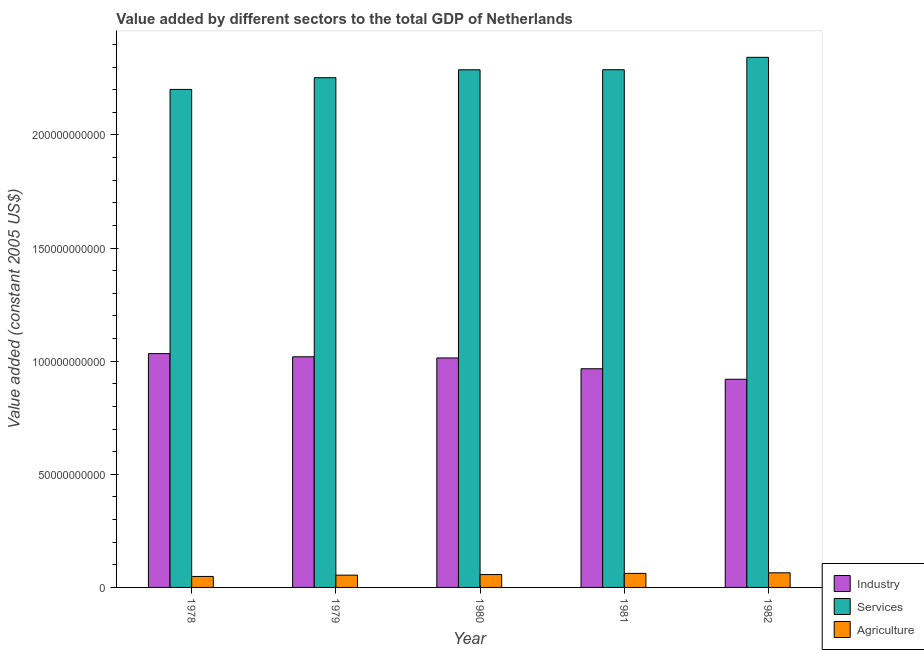How many different coloured bars are there?
Your response must be concise. 3. How many groups of bars are there?
Provide a succinct answer. 5. Are the number of bars on each tick of the X-axis equal?
Make the answer very short. Yes. How many bars are there on the 1st tick from the right?
Make the answer very short. 3. What is the label of the 4th group of bars from the left?
Provide a succinct answer. 1981. What is the value added by services in 1978?
Offer a very short reply. 2.20e+11. Across all years, what is the maximum value added by industrial sector?
Make the answer very short. 1.03e+11. Across all years, what is the minimum value added by agricultural sector?
Your answer should be compact. 4.85e+09. In which year was the value added by agricultural sector maximum?
Your answer should be compact. 1982. What is the total value added by industrial sector in the graph?
Your response must be concise. 4.95e+11. What is the difference between the value added by industrial sector in 1979 and that in 1981?
Provide a short and direct response. 5.29e+09. What is the difference between the value added by agricultural sector in 1982 and the value added by industrial sector in 1978?
Your response must be concise. 1.61e+09. What is the average value added by agricultural sector per year?
Make the answer very short. 5.73e+09. In how many years, is the value added by agricultural sector greater than 200000000000 US$?
Offer a very short reply. 0. What is the ratio of the value added by services in 1978 to that in 1982?
Offer a terse response. 0.94. What is the difference between the highest and the second highest value added by agricultural sector?
Offer a terse response. 2.62e+08. What is the difference between the highest and the lowest value added by industrial sector?
Provide a succinct answer. 1.13e+1. In how many years, is the value added by agricultural sector greater than the average value added by agricultural sector taken over all years?
Provide a short and direct response. 2. What does the 2nd bar from the left in 1981 represents?
Ensure brevity in your answer.  Services. What does the 3rd bar from the right in 1978 represents?
Provide a short and direct response. Industry. Is it the case that in every year, the sum of the value added by industrial sector and value added by services is greater than the value added by agricultural sector?
Offer a very short reply. Yes. Are all the bars in the graph horizontal?
Keep it short and to the point. No. How many years are there in the graph?
Ensure brevity in your answer.  5. Are the values on the major ticks of Y-axis written in scientific E-notation?
Your answer should be very brief. No. Does the graph contain any zero values?
Offer a terse response. No. Does the graph contain grids?
Offer a very short reply. No. Where does the legend appear in the graph?
Provide a short and direct response. Bottom right. How are the legend labels stacked?
Give a very brief answer. Vertical. What is the title of the graph?
Your answer should be compact. Value added by different sectors to the total GDP of Netherlands. Does "Communicable diseases" appear as one of the legend labels in the graph?
Provide a short and direct response. No. What is the label or title of the Y-axis?
Your answer should be very brief. Value added (constant 2005 US$). What is the Value added (constant 2005 US$) in Industry in 1978?
Offer a terse response. 1.03e+11. What is the Value added (constant 2005 US$) in Services in 1978?
Ensure brevity in your answer.  2.20e+11. What is the Value added (constant 2005 US$) of Agriculture in 1978?
Offer a very short reply. 4.85e+09. What is the Value added (constant 2005 US$) of Industry in 1979?
Your answer should be very brief. 1.02e+11. What is the Value added (constant 2005 US$) of Services in 1979?
Make the answer very short. 2.25e+11. What is the Value added (constant 2005 US$) of Agriculture in 1979?
Give a very brief answer. 5.43e+09. What is the Value added (constant 2005 US$) of Industry in 1980?
Offer a very short reply. 1.01e+11. What is the Value added (constant 2005 US$) of Services in 1980?
Make the answer very short. 2.29e+11. What is the Value added (constant 2005 US$) in Agriculture in 1980?
Your answer should be compact. 5.69e+09. What is the Value added (constant 2005 US$) in Industry in 1981?
Your answer should be very brief. 9.67e+1. What is the Value added (constant 2005 US$) of Services in 1981?
Provide a succinct answer. 2.29e+11. What is the Value added (constant 2005 US$) of Agriculture in 1981?
Your response must be concise. 6.20e+09. What is the Value added (constant 2005 US$) in Industry in 1982?
Offer a terse response. 9.20e+1. What is the Value added (constant 2005 US$) in Services in 1982?
Offer a terse response. 2.34e+11. What is the Value added (constant 2005 US$) in Agriculture in 1982?
Your answer should be very brief. 6.46e+09. Across all years, what is the maximum Value added (constant 2005 US$) of Industry?
Make the answer very short. 1.03e+11. Across all years, what is the maximum Value added (constant 2005 US$) in Services?
Make the answer very short. 2.34e+11. Across all years, what is the maximum Value added (constant 2005 US$) in Agriculture?
Make the answer very short. 6.46e+09. Across all years, what is the minimum Value added (constant 2005 US$) of Industry?
Keep it short and to the point. 9.20e+1. Across all years, what is the minimum Value added (constant 2005 US$) in Services?
Your answer should be very brief. 2.20e+11. Across all years, what is the minimum Value added (constant 2005 US$) in Agriculture?
Keep it short and to the point. 4.85e+09. What is the total Value added (constant 2005 US$) in Industry in the graph?
Ensure brevity in your answer.  4.95e+11. What is the total Value added (constant 2005 US$) of Services in the graph?
Make the answer very short. 1.14e+12. What is the total Value added (constant 2005 US$) in Agriculture in the graph?
Keep it short and to the point. 2.86e+1. What is the difference between the Value added (constant 2005 US$) of Industry in 1978 and that in 1979?
Offer a very short reply. 1.40e+09. What is the difference between the Value added (constant 2005 US$) in Services in 1978 and that in 1979?
Your answer should be compact. -5.17e+09. What is the difference between the Value added (constant 2005 US$) of Agriculture in 1978 and that in 1979?
Keep it short and to the point. -5.73e+08. What is the difference between the Value added (constant 2005 US$) of Industry in 1978 and that in 1980?
Make the answer very short. 1.91e+09. What is the difference between the Value added (constant 2005 US$) of Services in 1978 and that in 1980?
Offer a terse response. -8.68e+09. What is the difference between the Value added (constant 2005 US$) in Agriculture in 1978 and that in 1980?
Ensure brevity in your answer.  -8.32e+08. What is the difference between the Value added (constant 2005 US$) of Industry in 1978 and that in 1981?
Make the answer very short. 6.69e+09. What is the difference between the Value added (constant 2005 US$) in Services in 1978 and that in 1981?
Your answer should be very brief. -8.70e+09. What is the difference between the Value added (constant 2005 US$) of Agriculture in 1978 and that in 1981?
Offer a very short reply. -1.34e+09. What is the difference between the Value added (constant 2005 US$) of Industry in 1978 and that in 1982?
Provide a succinct answer. 1.13e+1. What is the difference between the Value added (constant 2005 US$) of Services in 1978 and that in 1982?
Keep it short and to the point. -1.42e+1. What is the difference between the Value added (constant 2005 US$) in Agriculture in 1978 and that in 1982?
Ensure brevity in your answer.  -1.61e+09. What is the difference between the Value added (constant 2005 US$) of Industry in 1979 and that in 1980?
Provide a short and direct response. 5.14e+08. What is the difference between the Value added (constant 2005 US$) of Services in 1979 and that in 1980?
Give a very brief answer. -3.51e+09. What is the difference between the Value added (constant 2005 US$) in Agriculture in 1979 and that in 1980?
Your answer should be compact. -2.59e+08. What is the difference between the Value added (constant 2005 US$) of Industry in 1979 and that in 1981?
Provide a succinct answer. 5.29e+09. What is the difference between the Value added (constant 2005 US$) of Services in 1979 and that in 1981?
Provide a short and direct response. -3.53e+09. What is the difference between the Value added (constant 2005 US$) in Agriculture in 1979 and that in 1981?
Keep it short and to the point. -7.72e+08. What is the difference between the Value added (constant 2005 US$) in Industry in 1979 and that in 1982?
Provide a short and direct response. 9.93e+09. What is the difference between the Value added (constant 2005 US$) in Services in 1979 and that in 1982?
Keep it short and to the point. -9.01e+09. What is the difference between the Value added (constant 2005 US$) in Agriculture in 1979 and that in 1982?
Your response must be concise. -1.03e+09. What is the difference between the Value added (constant 2005 US$) of Industry in 1980 and that in 1981?
Give a very brief answer. 4.78e+09. What is the difference between the Value added (constant 2005 US$) of Services in 1980 and that in 1981?
Provide a short and direct response. -2.19e+07. What is the difference between the Value added (constant 2005 US$) in Agriculture in 1980 and that in 1981?
Offer a very short reply. -5.13e+08. What is the difference between the Value added (constant 2005 US$) of Industry in 1980 and that in 1982?
Make the answer very short. 9.42e+09. What is the difference between the Value added (constant 2005 US$) of Services in 1980 and that in 1982?
Keep it short and to the point. -5.50e+09. What is the difference between the Value added (constant 2005 US$) of Agriculture in 1980 and that in 1982?
Provide a short and direct response. -7.75e+08. What is the difference between the Value added (constant 2005 US$) of Industry in 1981 and that in 1982?
Offer a terse response. 4.64e+09. What is the difference between the Value added (constant 2005 US$) in Services in 1981 and that in 1982?
Offer a very short reply. -5.48e+09. What is the difference between the Value added (constant 2005 US$) in Agriculture in 1981 and that in 1982?
Your response must be concise. -2.62e+08. What is the difference between the Value added (constant 2005 US$) of Industry in 1978 and the Value added (constant 2005 US$) of Services in 1979?
Your answer should be very brief. -1.22e+11. What is the difference between the Value added (constant 2005 US$) in Industry in 1978 and the Value added (constant 2005 US$) in Agriculture in 1979?
Give a very brief answer. 9.79e+1. What is the difference between the Value added (constant 2005 US$) of Services in 1978 and the Value added (constant 2005 US$) of Agriculture in 1979?
Ensure brevity in your answer.  2.15e+11. What is the difference between the Value added (constant 2005 US$) in Industry in 1978 and the Value added (constant 2005 US$) in Services in 1980?
Your response must be concise. -1.25e+11. What is the difference between the Value added (constant 2005 US$) of Industry in 1978 and the Value added (constant 2005 US$) of Agriculture in 1980?
Offer a very short reply. 9.77e+1. What is the difference between the Value added (constant 2005 US$) in Services in 1978 and the Value added (constant 2005 US$) in Agriculture in 1980?
Your answer should be very brief. 2.14e+11. What is the difference between the Value added (constant 2005 US$) in Industry in 1978 and the Value added (constant 2005 US$) in Services in 1981?
Provide a short and direct response. -1.25e+11. What is the difference between the Value added (constant 2005 US$) of Industry in 1978 and the Value added (constant 2005 US$) of Agriculture in 1981?
Make the answer very short. 9.71e+1. What is the difference between the Value added (constant 2005 US$) in Services in 1978 and the Value added (constant 2005 US$) in Agriculture in 1981?
Ensure brevity in your answer.  2.14e+11. What is the difference between the Value added (constant 2005 US$) of Industry in 1978 and the Value added (constant 2005 US$) of Services in 1982?
Offer a terse response. -1.31e+11. What is the difference between the Value added (constant 2005 US$) of Industry in 1978 and the Value added (constant 2005 US$) of Agriculture in 1982?
Offer a terse response. 9.69e+1. What is the difference between the Value added (constant 2005 US$) of Services in 1978 and the Value added (constant 2005 US$) of Agriculture in 1982?
Offer a terse response. 2.14e+11. What is the difference between the Value added (constant 2005 US$) of Industry in 1979 and the Value added (constant 2005 US$) of Services in 1980?
Your response must be concise. -1.27e+11. What is the difference between the Value added (constant 2005 US$) of Industry in 1979 and the Value added (constant 2005 US$) of Agriculture in 1980?
Make the answer very short. 9.63e+1. What is the difference between the Value added (constant 2005 US$) of Services in 1979 and the Value added (constant 2005 US$) of Agriculture in 1980?
Keep it short and to the point. 2.20e+11. What is the difference between the Value added (constant 2005 US$) in Industry in 1979 and the Value added (constant 2005 US$) in Services in 1981?
Your answer should be very brief. -1.27e+11. What is the difference between the Value added (constant 2005 US$) of Industry in 1979 and the Value added (constant 2005 US$) of Agriculture in 1981?
Make the answer very short. 9.57e+1. What is the difference between the Value added (constant 2005 US$) of Services in 1979 and the Value added (constant 2005 US$) of Agriculture in 1981?
Keep it short and to the point. 2.19e+11. What is the difference between the Value added (constant 2005 US$) of Industry in 1979 and the Value added (constant 2005 US$) of Services in 1982?
Provide a succinct answer. -1.32e+11. What is the difference between the Value added (constant 2005 US$) of Industry in 1979 and the Value added (constant 2005 US$) of Agriculture in 1982?
Your response must be concise. 9.55e+1. What is the difference between the Value added (constant 2005 US$) of Services in 1979 and the Value added (constant 2005 US$) of Agriculture in 1982?
Ensure brevity in your answer.  2.19e+11. What is the difference between the Value added (constant 2005 US$) in Industry in 1980 and the Value added (constant 2005 US$) in Services in 1981?
Offer a very short reply. -1.27e+11. What is the difference between the Value added (constant 2005 US$) in Industry in 1980 and the Value added (constant 2005 US$) in Agriculture in 1981?
Offer a terse response. 9.52e+1. What is the difference between the Value added (constant 2005 US$) in Services in 1980 and the Value added (constant 2005 US$) in Agriculture in 1981?
Your answer should be compact. 2.23e+11. What is the difference between the Value added (constant 2005 US$) of Industry in 1980 and the Value added (constant 2005 US$) of Services in 1982?
Your answer should be compact. -1.33e+11. What is the difference between the Value added (constant 2005 US$) in Industry in 1980 and the Value added (constant 2005 US$) in Agriculture in 1982?
Your response must be concise. 9.50e+1. What is the difference between the Value added (constant 2005 US$) of Services in 1980 and the Value added (constant 2005 US$) of Agriculture in 1982?
Your response must be concise. 2.22e+11. What is the difference between the Value added (constant 2005 US$) in Industry in 1981 and the Value added (constant 2005 US$) in Services in 1982?
Keep it short and to the point. -1.38e+11. What is the difference between the Value added (constant 2005 US$) of Industry in 1981 and the Value added (constant 2005 US$) of Agriculture in 1982?
Offer a very short reply. 9.02e+1. What is the difference between the Value added (constant 2005 US$) in Services in 1981 and the Value added (constant 2005 US$) in Agriculture in 1982?
Keep it short and to the point. 2.22e+11. What is the average Value added (constant 2005 US$) of Industry per year?
Your response must be concise. 9.91e+1. What is the average Value added (constant 2005 US$) of Services per year?
Provide a succinct answer. 2.27e+11. What is the average Value added (constant 2005 US$) of Agriculture per year?
Make the answer very short. 5.73e+09. In the year 1978, what is the difference between the Value added (constant 2005 US$) in Industry and Value added (constant 2005 US$) in Services?
Make the answer very short. -1.17e+11. In the year 1978, what is the difference between the Value added (constant 2005 US$) in Industry and Value added (constant 2005 US$) in Agriculture?
Make the answer very short. 9.85e+1. In the year 1978, what is the difference between the Value added (constant 2005 US$) in Services and Value added (constant 2005 US$) in Agriculture?
Give a very brief answer. 2.15e+11. In the year 1979, what is the difference between the Value added (constant 2005 US$) of Industry and Value added (constant 2005 US$) of Services?
Provide a succinct answer. -1.23e+11. In the year 1979, what is the difference between the Value added (constant 2005 US$) in Industry and Value added (constant 2005 US$) in Agriculture?
Provide a succinct answer. 9.65e+1. In the year 1979, what is the difference between the Value added (constant 2005 US$) in Services and Value added (constant 2005 US$) in Agriculture?
Provide a short and direct response. 2.20e+11. In the year 1980, what is the difference between the Value added (constant 2005 US$) of Industry and Value added (constant 2005 US$) of Services?
Make the answer very short. -1.27e+11. In the year 1980, what is the difference between the Value added (constant 2005 US$) of Industry and Value added (constant 2005 US$) of Agriculture?
Provide a short and direct response. 9.57e+1. In the year 1980, what is the difference between the Value added (constant 2005 US$) in Services and Value added (constant 2005 US$) in Agriculture?
Keep it short and to the point. 2.23e+11. In the year 1981, what is the difference between the Value added (constant 2005 US$) in Industry and Value added (constant 2005 US$) in Services?
Offer a very short reply. -1.32e+11. In the year 1981, what is the difference between the Value added (constant 2005 US$) of Industry and Value added (constant 2005 US$) of Agriculture?
Provide a succinct answer. 9.05e+1. In the year 1981, what is the difference between the Value added (constant 2005 US$) of Services and Value added (constant 2005 US$) of Agriculture?
Offer a very short reply. 2.23e+11. In the year 1982, what is the difference between the Value added (constant 2005 US$) of Industry and Value added (constant 2005 US$) of Services?
Provide a short and direct response. -1.42e+11. In the year 1982, what is the difference between the Value added (constant 2005 US$) in Industry and Value added (constant 2005 US$) in Agriculture?
Provide a succinct answer. 8.55e+1. In the year 1982, what is the difference between the Value added (constant 2005 US$) of Services and Value added (constant 2005 US$) of Agriculture?
Keep it short and to the point. 2.28e+11. What is the ratio of the Value added (constant 2005 US$) of Industry in 1978 to that in 1979?
Your answer should be compact. 1.01. What is the ratio of the Value added (constant 2005 US$) of Agriculture in 1978 to that in 1979?
Keep it short and to the point. 0.89. What is the ratio of the Value added (constant 2005 US$) of Industry in 1978 to that in 1980?
Provide a short and direct response. 1.02. What is the ratio of the Value added (constant 2005 US$) of Services in 1978 to that in 1980?
Provide a short and direct response. 0.96. What is the ratio of the Value added (constant 2005 US$) of Agriculture in 1978 to that in 1980?
Your answer should be compact. 0.85. What is the ratio of the Value added (constant 2005 US$) in Industry in 1978 to that in 1981?
Your response must be concise. 1.07. What is the ratio of the Value added (constant 2005 US$) of Agriculture in 1978 to that in 1981?
Your response must be concise. 0.78. What is the ratio of the Value added (constant 2005 US$) of Industry in 1978 to that in 1982?
Provide a short and direct response. 1.12. What is the ratio of the Value added (constant 2005 US$) of Services in 1978 to that in 1982?
Make the answer very short. 0.94. What is the ratio of the Value added (constant 2005 US$) of Agriculture in 1978 to that in 1982?
Provide a succinct answer. 0.75. What is the ratio of the Value added (constant 2005 US$) of Industry in 1979 to that in 1980?
Keep it short and to the point. 1.01. What is the ratio of the Value added (constant 2005 US$) in Services in 1979 to that in 1980?
Provide a succinct answer. 0.98. What is the ratio of the Value added (constant 2005 US$) in Agriculture in 1979 to that in 1980?
Ensure brevity in your answer.  0.95. What is the ratio of the Value added (constant 2005 US$) in Industry in 1979 to that in 1981?
Ensure brevity in your answer.  1.05. What is the ratio of the Value added (constant 2005 US$) in Services in 1979 to that in 1981?
Your answer should be compact. 0.98. What is the ratio of the Value added (constant 2005 US$) of Agriculture in 1979 to that in 1981?
Offer a very short reply. 0.88. What is the ratio of the Value added (constant 2005 US$) in Industry in 1979 to that in 1982?
Ensure brevity in your answer.  1.11. What is the ratio of the Value added (constant 2005 US$) in Services in 1979 to that in 1982?
Your response must be concise. 0.96. What is the ratio of the Value added (constant 2005 US$) of Agriculture in 1979 to that in 1982?
Your response must be concise. 0.84. What is the ratio of the Value added (constant 2005 US$) of Industry in 1980 to that in 1981?
Offer a terse response. 1.05. What is the ratio of the Value added (constant 2005 US$) in Agriculture in 1980 to that in 1981?
Your response must be concise. 0.92. What is the ratio of the Value added (constant 2005 US$) of Industry in 1980 to that in 1982?
Your answer should be very brief. 1.1. What is the ratio of the Value added (constant 2005 US$) in Services in 1980 to that in 1982?
Offer a terse response. 0.98. What is the ratio of the Value added (constant 2005 US$) of Agriculture in 1980 to that in 1982?
Give a very brief answer. 0.88. What is the ratio of the Value added (constant 2005 US$) of Industry in 1981 to that in 1982?
Give a very brief answer. 1.05. What is the ratio of the Value added (constant 2005 US$) in Services in 1981 to that in 1982?
Provide a short and direct response. 0.98. What is the ratio of the Value added (constant 2005 US$) of Agriculture in 1981 to that in 1982?
Offer a terse response. 0.96. What is the difference between the highest and the second highest Value added (constant 2005 US$) in Industry?
Provide a short and direct response. 1.40e+09. What is the difference between the highest and the second highest Value added (constant 2005 US$) in Services?
Give a very brief answer. 5.48e+09. What is the difference between the highest and the second highest Value added (constant 2005 US$) of Agriculture?
Offer a very short reply. 2.62e+08. What is the difference between the highest and the lowest Value added (constant 2005 US$) in Industry?
Make the answer very short. 1.13e+1. What is the difference between the highest and the lowest Value added (constant 2005 US$) in Services?
Offer a very short reply. 1.42e+1. What is the difference between the highest and the lowest Value added (constant 2005 US$) in Agriculture?
Give a very brief answer. 1.61e+09. 